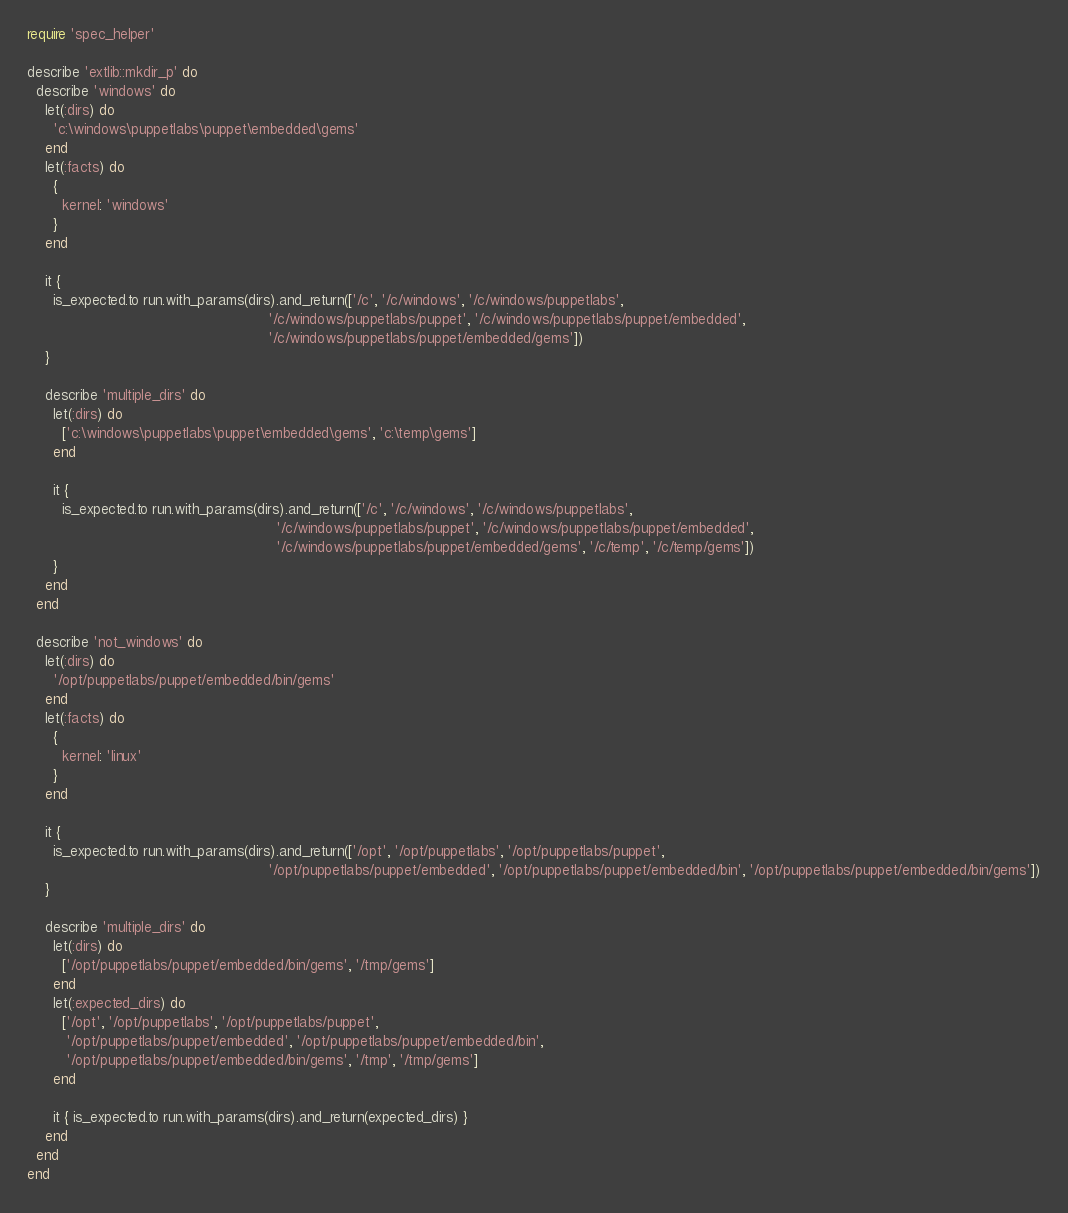Convert code to text. <code><loc_0><loc_0><loc_500><loc_500><_Ruby_>require 'spec_helper'

describe 'extlib::mkdir_p' do
  describe 'windows' do
    let(:dirs) do
      'c:\windows\puppetlabs\puppet\embedded\gems'
    end
    let(:facts) do
      {
        kernel: 'windows'
      }
    end

    it {
      is_expected.to run.with_params(dirs).and_return(['/c', '/c/windows', '/c/windows/puppetlabs',
                                                       '/c/windows/puppetlabs/puppet', '/c/windows/puppetlabs/puppet/embedded',
                                                       '/c/windows/puppetlabs/puppet/embedded/gems'])
    }

    describe 'multiple_dirs' do
      let(:dirs) do
        ['c:\windows\puppetlabs\puppet\embedded\gems', 'c:\temp\gems']
      end

      it {
        is_expected.to run.with_params(dirs).and_return(['/c', '/c/windows', '/c/windows/puppetlabs',
                                                         '/c/windows/puppetlabs/puppet', '/c/windows/puppetlabs/puppet/embedded',
                                                         '/c/windows/puppetlabs/puppet/embedded/gems', '/c/temp', '/c/temp/gems'])
      }
    end
  end

  describe 'not_windows' do
    let(:dirs) do
      '/opt/puppetlabs/puppet/embedded/bin/gems'
    end
    let(:facts) do
      {
        kernel: 'linux'
      }
    end

    it {
      is_expected.to run.with_params(dirs).and_return(['/opt', '/opt/puppetlabs', '/opt/puppetlabs/puppet',
                                                       '/opt/puppetlabs/puppet/embedded', '/opt/puppetlabs/puppet/embedded/bin', '/opt/puppetlabs/puppet/embedded/bin/gems'])
    }

    describe 'multiple_dirs' do
      let(:dirs) do
        ['/opt/puppetlabs/puppet/embedded/bin/gems', '/tmp/gems']
      end
      let(:expected_dirs) do
        ['/opt', '/opt/puppetlabs', '/opt/puppetlabs/puppet',
         '/opt/puppetlabs/puppet/embedded', '/opt/puppetlabs/puppet/embedded/bin',
         '/opt/puppetlabs/puppet/embedded/bin/gems', '/tmp', '/tmp/gems']
      end

      it { is_expected.to run.with_params(dirs).and_return(expected_dirs) }
    end
  end
end
</code> 